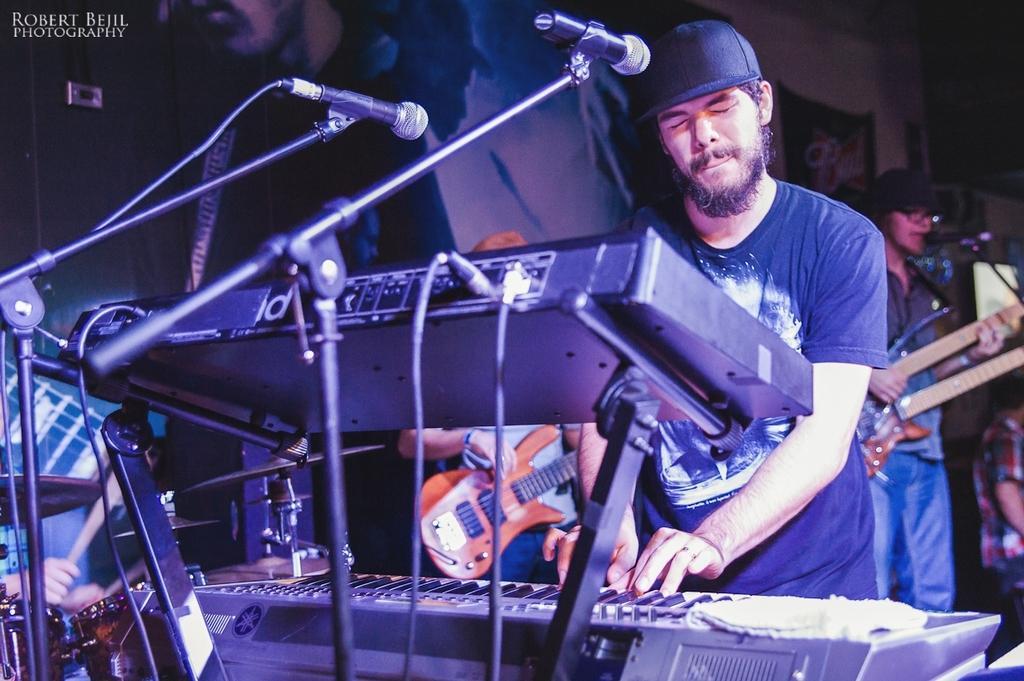Please provide a concise description of this image. In this image there are three person playing an musical instrument. At back side you can see a wall. There is a mic and a stand. 